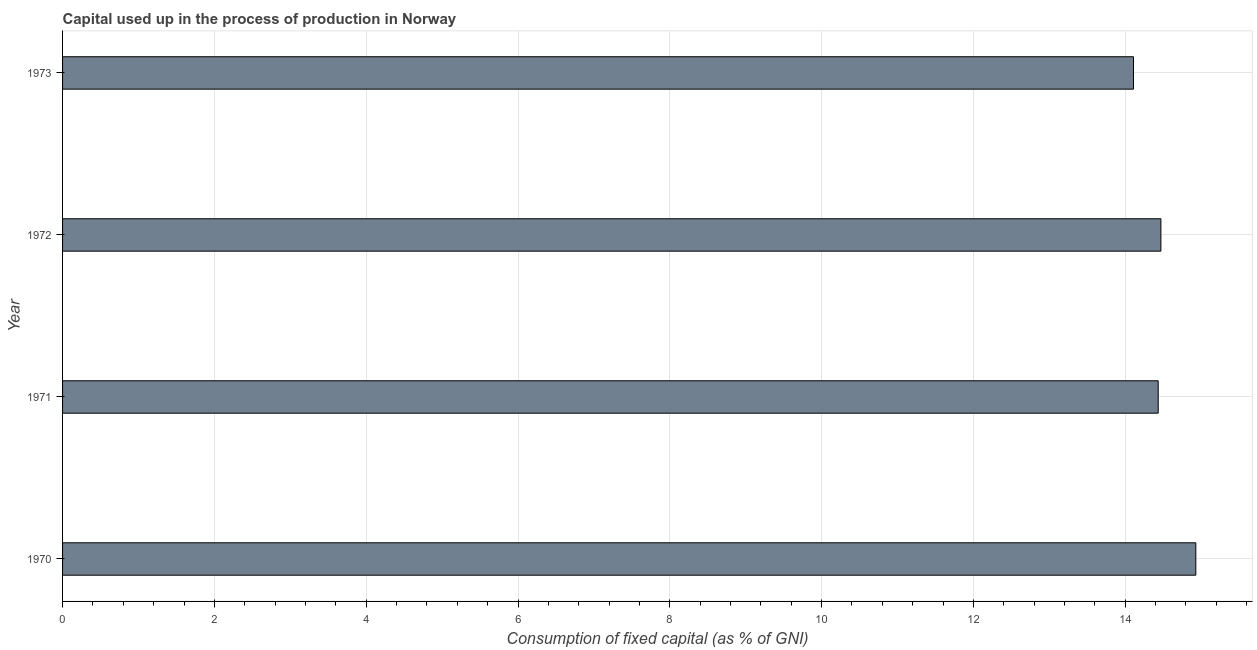What is the title of the graph?
Offer a very short reply. Capital used up in the process of production in Norway. What is the label or title of the X-axis?
Offer a terse response. Consumption of fixed capital (as % of GNI). What is the consumption of fixed capital in 1970?
Your response must be concise. 14.93. Across all years, what is the maximum consumption of fixed capital?
Provide a succinct answer. 14.93. Across all years, what is the minimum consumption of fixed capital?
Your response must be concise. 14.11. In which year was the consumption of fixed capital minimum?
Give a very brief answer. 1973. What is the sum of the consumption of fixed capital?
Your response must be concise. 57.94. What is the difference between the consumption of fixed capital in 1970 and 1972?
Your answer should be compact. 0.46. What is the average consumption of fixed capital per year?
Ensure brevity in your answer.  14.49. What is the median consumption of fixed capital?
Ensure brevity in your answer.  14.45. Do a majority of the years between 1972 and 1970 (inclusive) have consumption of fixed capital greater than 14.8 %?
Offer a terse response. Yes. What is the ratio of the consumption of fixed capital in 1971 to that in 1973?
Offer a terse response. 1.02. Is the consumption of fixed capital in 1971 less than that in 1972?
Make the answer very short. Yes. What is the difference between the highest and the second highest consumption of fixed capital?
Offer a terse response. 0.46. What is the difference between the highest and the lowest consumption of fixed capital?
Give a very brief answer. 0.82. In how many years, is the consumption of fixed capital greater than the average consumption of fixed capital taken over all years?
Your answer should be compact. 1. How many bars are there?
Give a very brief answer. 4. How many years are there in the graph?
Keep it short and to the point. 4. Are the values on the major ticks of X-axis written in scientific E-notation?
Give a very brief answer. No. What is the Consumption of fixed capital (as % of GNI) in 1970?
Keep it short and to the point. 14.93. What is the Consumption of fixed capital (as % of GNI) of 1971?
Your answer should be very brief. 14.43. What is the Consumption of fixed capital (as % of GNI) in 1972?
Give a very brief answer. 14.47. What is the Consumption of fixed capital (as % of GNI) in 1973?
Offer a very short reply. 14.11. What is the difference between the Consumption of fixed capital (as % of GNI) in 1970 and 1971?
Provide a succinct answer. 0.5. What is the difference between the Consumption of fixed capital (as % of GNI) in 1970 and 1972?
Ensure brevity in your answer.  0.46. What is the difference between the Consumption of fixed capital (as % of GNI) in 1970 and 1973?
Offer a terse response. 0.82. What is the difference between the Consumption of fixed capital (as % of GNI) in 1971 and 1972?
Offer a very short reply. -0.04. What is the difference between the Consumption of fixed capital (as % of GNI) in 1971 and 1973?
Make the answer very short. 0.33. What is the difference between the Consumption of fixed capital (as % of GNI) in 1972 and 1973?
Provide a succinct answer. 0.36. What is the ratio of the Consumption of fixed capital (as % of GNI) in 1970 to that in 1971?
Give a very brief answer. 1.03. What is the ratio of the Consumption of fixed capital (as % of GNI) in 1970 to that in 1972?
Ensure brevity in your answer.  1.03. What is the ratio of the Consumption of fixed capital (as % of GNI) in 1970 to that in 1973?
Your response must be concise. 1.06. What is the ratio of the Consumption of fixed capital (as % of GNI) in 1971 to that in 1972?
Give a very brief answer. 1. What is the ratio of the Consumption of fixed capital (as % of GNI) in 1971 to that in 1973?
Ensure brevity in your answer.  1.02. 